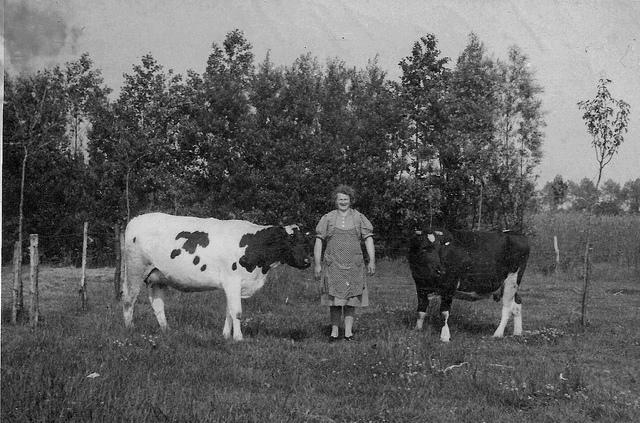What is the woman's orientation in relation to the cows?

Choices:
A) in between
B) behind
C) in front
D) below in between 